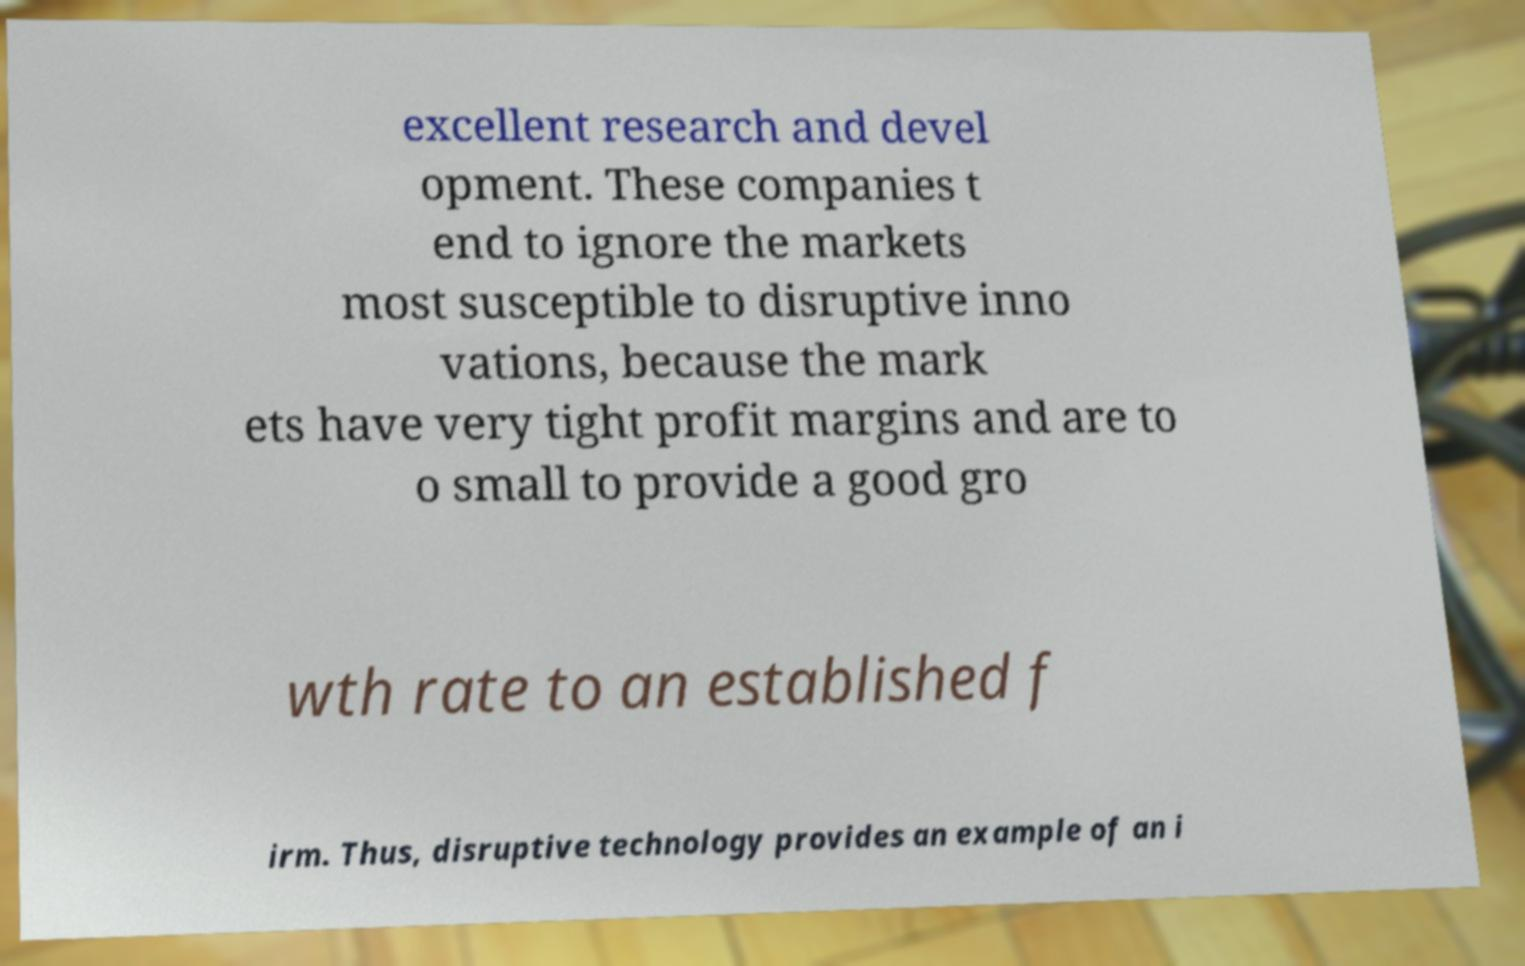Please identify and transcribe the text found in this image. excellent research and devel opment. These companies t end to ignore the markets most susceptible to disruptive inno vations, because the mark ets have very tight profit margins and are to o small to provide a good gro wth rate to an established f irm. Thus, disruptive technology provides an example of an i 